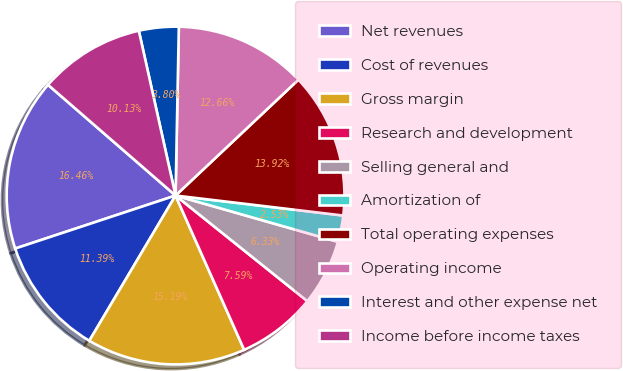Convert chart. <chart><loc_0><loc_0><loc_500><loc_500><pie_chart><fcel>Net revenues<fcel>Cost of revenues<fcel>Gross margin<fcel>Research and development<fcel>Selling general and<fcel>Amortization of<fcel>Total operating expenses<fcel>Operating income<fcel>Interest and other expense net<fcel>Income before income taxes<nl><fcel>16.46%<fcel>11.39%<fcel>15.19%<fcel>7.59%<fcel>6.33%<fcel>2.53%<fcel>13.92%<fcel>12.66%<fcel>3.8%<fcel>10.13%<nl></chart> 